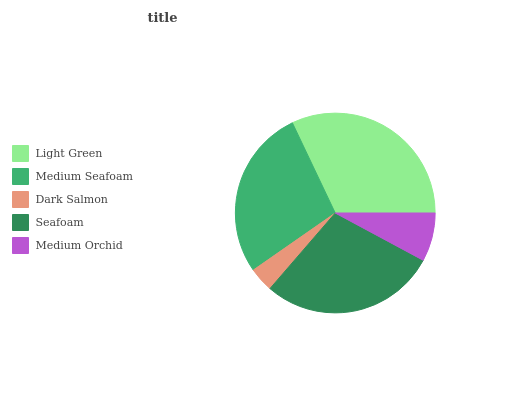Is Dark Salmon the minimum?
Answer yes or no. Yes. Is Light Green the maximum?
Answer yes or no. Yes. Is Medium Seafoam the minimum?
Answer yes or no. No. Is Medium Seafoam the maximum?
Answer yes or no. No. Is Light Green greater than Medium Seafoam?
Answer yes or no. Yes. Is Medium Seafoam less than Light Green?
Answer yes or no. Yes. Is Medium Seafoam greater than Light Green?
Answer yes or no. No. Is Light Green less than Medium Seafoam?
Answer yes or no. No. Is Medium Seafoam the high median?
Answer yes or no. Yes. Is Medium Seafoam the low median?
Answer yes or no. Yes. Is Light Green the high median?
Answer yes or no. No. Is Dark Salmon the low median?
Answer yes or no. No. 